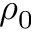<formula> <loc_0><loc_0><loc_500><loc_500>\rho _ { 0 }</formula> 